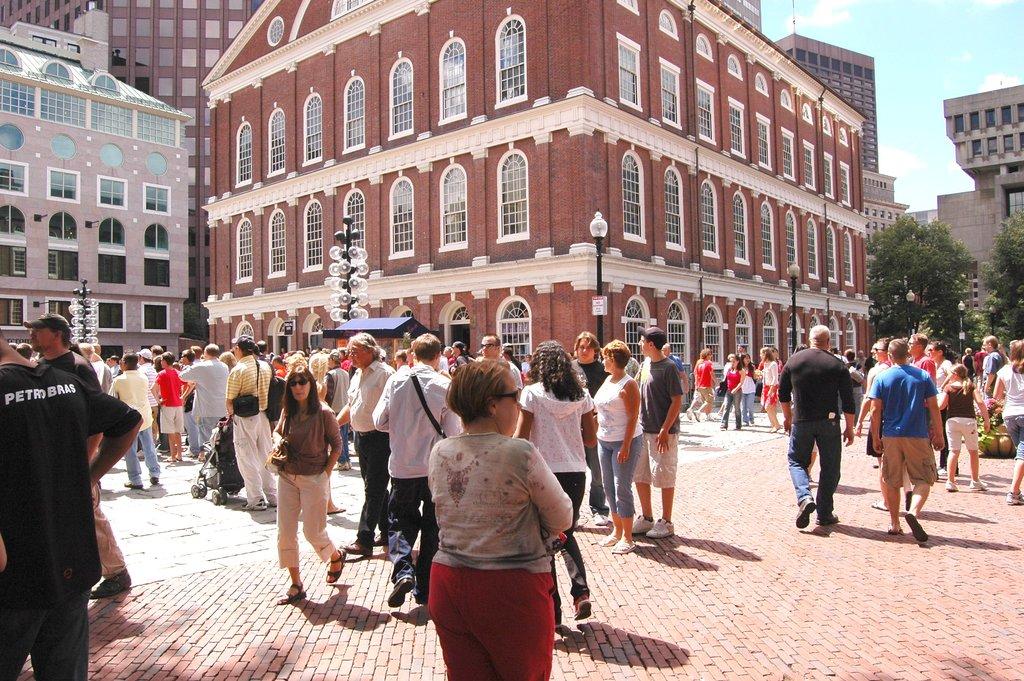What are the first 3 letters on the back of the black shirt?
Offer a very short reply. Pet. What is the first letter on the back of the black shirt?
Your answer should be very brief. P. 